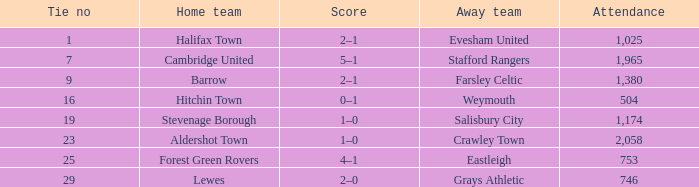Which team was playing away in a deadlock not greater than 16 against forest green rovers at home? Eastleigh. 